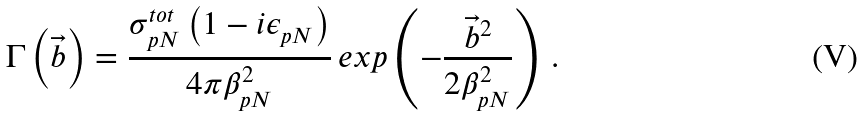<formula> <loc_0><loc_0><loc_500><loc_500>\Gamma \left ( \vec { b } \right ) = \frac { { \sigma ^ { t o t } _ { p N } } \left ( 1 - i { \epsilon _ { p N } } \right ) } { 4 \pi \beta _ { p N } ^ { 2 } } \, e x p \left ( - \frac { \vec { b } ^ { 2 } } { 2 \beta _ { p N } ^ { 2 } } \right ) \, .</formula> 